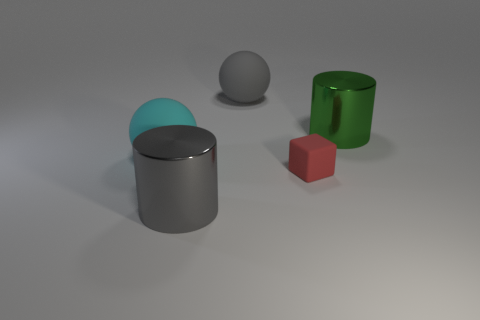What is the shape of the gray rubber thing that is the same size as the green object?
Provide a succinct answer. Sphere. Are there any other things that have the same shape as the tiny thing?
Ensure brevity in your answer.  No. Is there any other thing that has the same size as the block?
Give a very brief answer. No. Is the number of large gray metal objects greater than the number of big spheres?
Ensure brevity in your answer.  No. There is a metallic thing that is left of the large gray rubber thing; what number of big things are to the left of it?
Your answer should be very brief. 1. There is a cyan thing; are there any large balls to the right of it?
Offer a very short reply. Yes. The large object behind the metallic cylinder that is right of the small red block is what shape?
Your answer should be very brief. Sphere. Are there fewer matte things that are left of the small thing than objects that are behind the large gray metallic object?
Your response must be concise. Yes. The other metallic thing that is the same shape as the green object is what color?
Give a very brief answer. Gray. What number of things are on the left side of the red block and in front of the cyan object?
Your answer should be very brief. 1. 